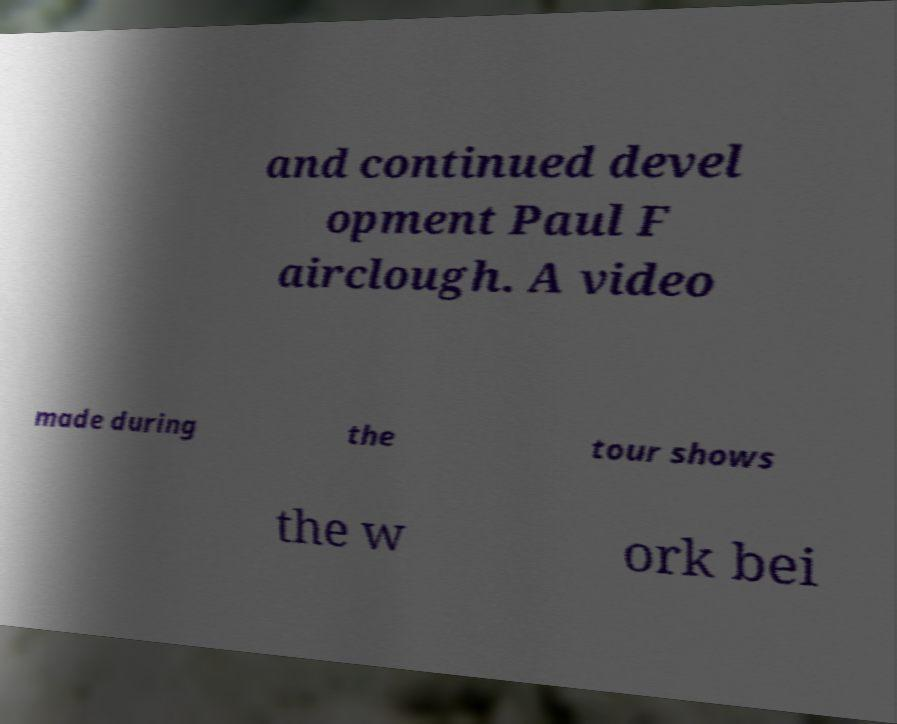Could you assist in decoding the text presented in this image and type it out clearly? and continued devel opment Paul F airclough. A video made during the tour shows the w ork bei 